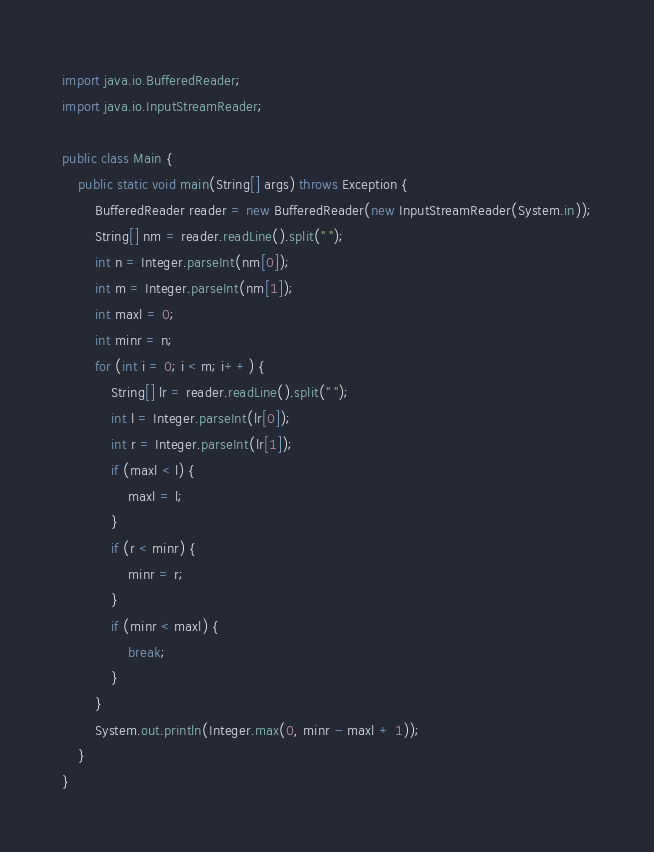Convert code to text. <code><loc_0><loc_0><loc_500><loc_500><_Java_>import java.io.BufferedReader;
import java.io.InputStreamReader;

public class Main {
    public static void main(String[] args) throws Exception {
        BufferedReader reader = new BufferedReader(new InputStreamReader(System.in));
        String[] nm = reader.readLine().split(" ");
        int n = Integer.parseInt(nm[0]);
        int m = Integer.parseInt(nm[1]);
        int maxl = 0;
        int minr = n;
        for (int i = 0; i < m; i++) {
            String[] lr = reader.readLine().split(" ");
            int l = Integer.parseInt(lr[0]);
            int r = Integer.parseInt(lr[1]);
            if (maxl < l) {
                maxl = l;
            }
            if (r < minr) {
                minr = r;
            }
            if (minr < maxl) {
                break;
            }
        }
        System.out.println(Integer.max(0, minr - maxl + 1));
    }
}
</code> 